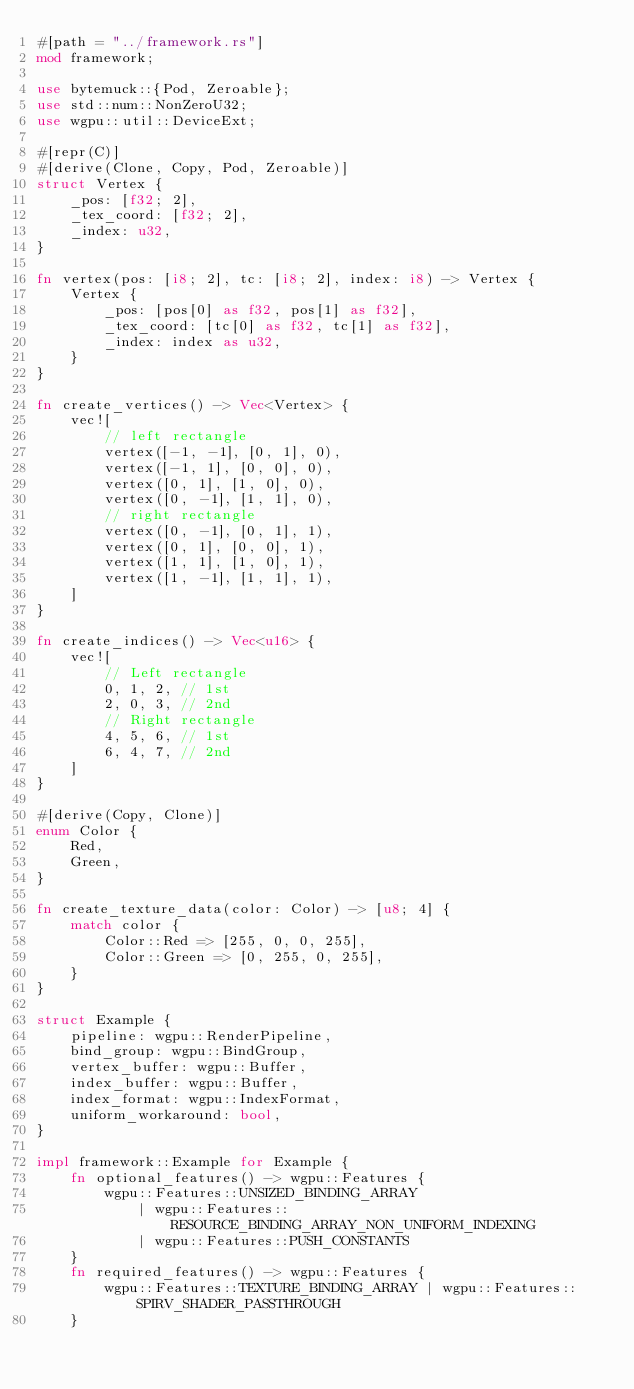<code> <loc_0><loc_0><loc_500><loc_500><_Rust_>#[path = "../framework.rs"]
mod framework;

use bytemuck::{Pod, Zeroable};
use std::num::NonZeroU32;
use wgpu::util::DeviceExt;

#[repr(C)]
#[derive(Clone, Copy, Pod, Zeroable)]
struct Vertex {
    _pos: [f32; 2],
    _tex_coord: [f32; 2],
    _index: u32,
}

fn vertex(pos: [i8; 2], tc: [i8; 2], index: i8) -> Vertex {
    Vertex {
        _pos: [pos[0] as f32, pos[1] as f32],
        _tex_coord: [tc[0] as f32, tc[1] as f32],
        _index: index as u32,
    }
}

fn create_vertices() -> Vec<Vertex> {
    vec![
        // left rectangle
        vertex([-1, -1], [0, 1], 0),
        vertex([-1, 1], [0, 0], 0),
        vertex([0, 1], [1, 0], 0),
        vertex([0, -1], [1, 1], 0),
        // right rectangle
        vertex([0, -1], [0, 1], 1),
        vertex([0, 1], [0, 0], 1),
        vertex([1, 1], [1, 0], 1),
        vertex([1, -1], [1, 1], 1),
    ]
}

fn create_indices() -> Vec<u16> {
    vec![
        // Left rectangle
        0, 1, 2, // 1st
        2, 0, 3, // 2nd
        // Right rectangle
        4, 5, 6, // 1st
        6, 4, 7, // 2nd
    ]
}

#[derive(Copy, Clone)]
enum Color {
    Red,
    Green,
}

fn create_texture_data(color: Color) -> [u8; 4] {
    match color {
        Color::Red => [255, 0, 0, 255],
        Color::Green => [0, 255, 0, 255],
    }
}

struct Example {
    pipeline: wgpu::RenderPipeline,
    bind_group: wgpu::BindGroup,
    vertex_buffer: wgpu::Buffer,
    index_buffer: wgpu::Buffer,
    index_format: wgpu::IndexFormat,
    uniform_workaround: bool,
}

impl framework::Example for Example {
    fn optional_features() -> wgpu::Features {
        wgpu::Features::UNSIZED_BINDING_ARRAY
            | wgpu::Features::RESOURCE_BINDING_ARRAY_NON_UNIFORM_INDEXING
            | wgpu::Features::PUSH_CONSTANTS
    }
    fn required_features() -> wgpu::Features {
        wgpu::Features::TEXTURE_BINDING_ARRAY | wgpu::Features::SPIRV_SHADER_PASSTHROUGH
    }</code> 